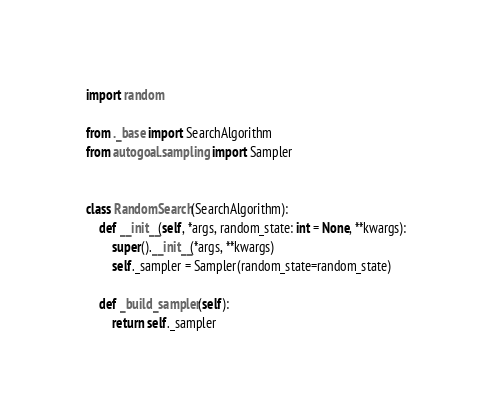<code> <loc_0><loc_0><loc_500><loc_500><_Python_>import random

from ._base import SearchAlgorithm
from autogoal.sampling import Sampler


class RandomSearch(SearchAlgorithm):
    def __init__(self, *args, random_state: int = None, **kwargs):
        super().__init__(*args, **kwargs)
        self._sampler = Sampler(random_state=random_state)

    def _build_sampler(self):
        return self._sampler
</code> 